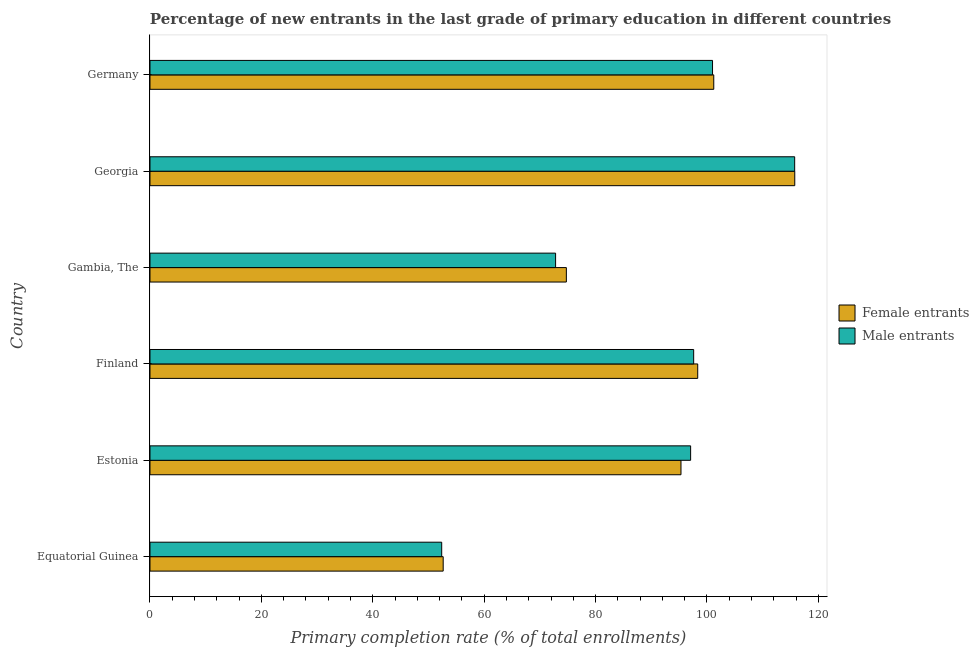How many different coloured bars are there?
Provide a short and direct response. 2. Are the number of bars per tick equal to the number of legend labels?
Keep it short and to the point. Yes. Are the number of bars on each tick of the Y-axis equal?
Offer a very short reply. Yes. How many bars are there on the 5th tick from the bottom?
Give a very brief answer. 2. What is the label of the 2nd group of bars from the top?
Your answer should be very brief. Georgia. What is the primary completion rate of female entrants in Georgia?
Your response must be concise. 115.76. Across all countries, what is the maximum primary completion rate of male entrants?
Your response must be concise. 115.74. Across all countries, what is the minimum primary completion rate of female entrants?
Your response must be concise. 52.64. In which country was the primary completion rate of male entrants maximum?
Provide a short and direct response. Georgia. In which country was the primary completion rate of male entrants minimum?
Make the answer very short. Equatorial Guinea. What is the total primary completion rate of female entrants in the graph?
Give a very brief answer. 538.03. What is the difference between the primary completion rate of female entrants in Estonia and that in Finland?
Offer a very short reply. -3. What is the difference between the primary completion rate of female entrants in Equatorial Guinea and the primary completion rate of male entrants in Gambia, The?
Give a very brief answer. -20.18. What is the average primary completion rate of female entrants per country?
Your answer should be very brief. 89.67. What is the difference between the primary completion rate of female entrants and primary completion rate of male entrants in Germany?
Offer a very short reply. 0.22. In how many countries, is the primary completion rate of female entrants greater than 92 %?
Your answer should be very brief. 4. What is the ratio of the primary completion rate of female entrants in Estonia to that in Georgia?
Provide a short and direct response. 0.82. Is the primary completion rate of male entrants in Georgia less than that in Germany?
Give a very brief answer. No. What is the difference between the highest and the second highest primary completion rate of male entrants?
Ensure brevity in your answer.  14.74. What is the difference between the highest and the lowest primary completion rate of female entrants?
Make the answer very short. 63.12. Is the sum of the primary completion rate of female entrants in Estonia and Gambia, The greater than the maximum primary completion rate of male entrants across all countries?
Provide a short and direct response. Yes. What does the 1st bar from the top in Gambia, The represents?
Your answer should be compact. Male entrants. What does the 1st bar from the bottom in Estonia represents?
Give a very brief answer. Female entrants. Are all the bars in the graph horizontal?
Provide a succinct answer. Yes. How many countries are there in the graph?
Give a very brief answer. 6. Are the values on the major ticks of X-axis written in scientific E-notation?
Your answer should be very brief. No. Does the graph contain any zero values?
Provide a short and direct response. No. Does the graph contain grids?
Offer a terse response. No. Where does the legend appear in the graph?
Provide a succinct answer. Center right. What is the title of the graph?
Offer a very short reply. Percentage of new entrants in the last grade of primary education in different countries. What is the label or title of the X-axis?
Your response must be concise. Primary completion rate (% of total enrollments). What is the Primary completion rate (% of total enrollments) of Female entrants in Equatorial Guinea?
Give a very brief answer. 52.64. What is the Primary completion rate (% of total enrollments) of Male entrants in Equatorial Guinea?
Offer a very short reply. 52.37. What is the Primary completion rate (% of total enrollments) in Female entrants in Estonia?
Give a very brief answer. 95.33. What is the Primary completion rate (% of total enrollments) in Male entrants in Estonia?
Make the answer very short. 97.06. What is the Primary completion rate (% of total enrollments) of Female entrants in Finland?
Provide a succinct answer. 98.33. What is the Primary completion rate (% of total enrollments) in Male entrants in Finland?
Provide a succinct answer. 97.61. What is the Primary completion rate (% of total enrollments) in Female entrants in Gambia, The?
Make the answer very short. 74.75. What is the Primary completion rate (% of total enrollments) in Male entrants in Gambia, The?
Provide a succinct answer. 72.82. What is the Primary completion rate (% of total enrollments) in Female entrants in Georgia?
Make the answer very short. 115.76. What is the Primary completion rate (% of total enrollments) in Male entrants in Georgia?
Provide a succinct answer. 115.74. What is the Primary completion rate (% of total enrollments) of Female entrants in Germany?
Provide a short and direct response. 101.22. What is the Primary completion rate (% of total enrollments) of Male entrants in Germany?
Your answer should be very brief. 101. Across all countries, what is the maximum Primary completion rate (% of total enrollments) in Female entrants?
Give a very brief answer. 115.76. Across all countries, what is the maximum Primary completion rate (% of total enrollments) of Male entrants?
Offer a very short reply. 115.74. Across all countries, what is the minimum Primary completion rate (% of total enrollments) in Female entrants?
Provide a succinct answer. 52.64. Across all countries, what is the minimum Primary completion rate (% of total enrollments) of Male entrants?
Your response must be concise. 52.37. What is the total Primary completion rate (% of total enrollments) in Female entrants in the graph?
Provide a succinct answer. 538.03. What is the total Primary completion rate (% of total enrollments) of Male entrants in the graph?
Give a very brief answer. 536.6. What is the difference between the Primary completion rate (% of total enrollments) in Female entrants in Equatorial Guinea and that in Estonia?
Provide a short and direct response. -42.69. What is the difference between the Primary completion rate (% of total enrollments) of Male entrants in Equatorial Guinea and that in Estonia?
Your response must be concise. -44.69. What is the difference between the Primary completion rate (% of total enrollments) of Female entrants in Equatorial Guinea and that in Finland?
Keep it short and to the point. -45.7. What is the difference between the Primary completion rate (% of total enrollments) of Male entrants in Equatorial Guinea and that in Finland?
Ensure brevity in your answer.  -45.24. What is the difference between the Primary completion rate (% of total enrollments) in Female entrants in Equatorial Guinea and that in Gambia, The?
Your answer should be compact. -22.11. What is the difference between the Primary completion rate (% of total enrollments) in Male entrants in Equatorial Guinea and that in Gambia, The?
Provide a succinct answer. -20.45. What is the difference between the Primary completion rate (% of total enrollments) of Female entrants in Equatorial Guinea and that in Georgia?
Give a very brief answer. -63.12. What is the difference between the Primary completion rate (% of total enrollments) of Male entrants in Equatorial Guinea and that in Georgia?
Provide a short and direct response. -63.37. What is the difference between the Primary completion rate (% of total enrollments) in Female entrants in Equatorial Guinea and that in Germany?
Give a very brief answer. -48.58. What is the difference between the Primary completion rate (% of total enrollments) of Male entrants in Equatorial Guinea and that in Germany?
Make the answer very short. -48.62. What is the difference between the Primary completion rate (% of total enrollments) of Female entrants in Estonia and that in Finland?
Make the answer very short. -3. What is the difference between the Primary completion rate (% of total enrollments) of Male entrants in Estonia and that in Finland?
Your response must be concise. -0.55. What is the difference between the Primary completion rate (% of total enrollments) in Female entrants in Estonia and that in Gambia, The?
Keep it short and to the point. 20.58. What is the difference between the Primary completion rate (% of total enrollments) of Male entrants in Estonia and that in Gambia, The?
Your response must be concise. 24.24. What is the difference between the Primary completion rate (% of total enrollments) in Female entrants in Estonia and that in Georgia?
Offer a very short reply. -20.43. What is the difference between the Primary completion rate (% of total enrollments) in Male entrants in Estonia and that in Georgia?
Provide a short and direct response. -18.68. What is the difference between the Primary completion rate (% of total enrollments) in Female entrants in Estonia and that in Germany?
Offer a terse response. -5.88. What is the difference between the Primary completion rate (% of total enrollments) in Male entrants in Estonia and that in Germany?
Provide a short and direct response. -3.93. What is the difference between the Primary completion rate (% of total enrollments) in Female entrants in Finland and that in Gambia, The?
Provide a succinct answer. 23.58. What is the difference between the Primary completion rate (% of total enrollments) of Male entrants in Finland and that in Gambia, The?
Give a very brief answer. 24.79. What is the difference between the Primary completion rate (% of total enrollments) of Female entrants in Finland and that in Georgia?
Ensure brevity in your answer.  -17.42. What is the difference between the Primary completion rate (% of total enrollments) of Male entrants in Finland and that in Georgia?
Your response must be concise. -18.13. What is the difference between the Primary completion rate (% of total enrollments) of Female entrants in Finland and that in Germany?
Provide a succinct answer. -2.88. What is the difference between the Primary completion rate (% of total enrollments) of Male entrants in Finland and that in Germany?
Give a very brief answer. -3.39. What is the difference between the Primary completion rate (% of total enrollments) of Female entrants in Gambia, The and that in Georgia?
Keep it short and to the point. -41.01. What is the difference between the Primary completion rate (% of total enrollments) in Male entrants in Gambia, The and that in Georgia?
Give a very brief answer. -42.92. What is the difference between the Primary completion rate (% of total enrollments) of Female entrants in Gambia, The and that in Germany?
Offer a very short reply. -26.47. What is the difference between the Primary completion rate (% of total enrollments) in Male entrants in Gambia, The and that in Germany?
Your response must be concise. -28.18. What is the difference between the Primary completion rate (% of total enrollments) of Female entrants in Georgia and that in Germany?
Ensure brevity in your answer.  14.54. What is the difference between the Primary completion rate (% of total enrollments) of Male entrants in Georgia and that in Germany?
Offer a terse response. 14.75. What is the difference between the Primary completion rate (% of total enrollments) of Female entrants in Equatorial Guinea and the Primary completion rate (% of total enrollments) of Male entrants in Estonia?
Keep it short and to the point. -44.43. What is the difference between the Primary completion rate (% of total enrollments) of Female entrants in Equatorial Guinea and the Primary completion rate (% of total enrollments) of Male entrants in Finland?
Provide a short and direct response. -44.97. What is the difference between the Primary completion rate (% of total enrollments) in Female entrants in Equatorial Guinea and the Primary completion rate (% of total enrollments) in Male entrants in Gambia, The?
Ensure brevity in your answer.  -20.18. What is the difference between the Primary completion rate (% of total enrollments) of Female entrants in Equatorial Guinea and the Primary completion rate (% of total enrollments) of Male entrants in Georgia?
Offer a terse response. -63.1. What is the difference between the Primary completion rate (% of total enrollments) in Female entrants in Equatorial Guinea and the Primary completion rate (% of total enrollments) in Male entrants in Germany?
Offer a very short reply. -48.36. What is the difference between the Primary completion rate (% of total enrollments) in Female entrants in Estonia and the Primary completion rate (% of total enrollments) in Male entrants in Finland?
Your response must be concise. -2.28. What is the difference between the Primary completion rate (% of total enrollments) in Female entrants in Estonia and the Primary completion rate (% of total enrollments) in Male entrants in Gambia, The?
Give a very brief answer. 22.51. What is the difference between the Primary completion rate (% of total enrollments) in Female entrants in Estonia and the Primary completion rate (% of total enrollments) in Male entrants in Georgia?
Make the answer very short. -20.41. What is the difference between the Primary completion rate (% of total enrollments) in Female entrants in Estonia and the Primary completion rate (% of total enrollments) in Male entrants in Germany?
Keep it short and to the point. -5.66. What is the difference between the Primary completion rate (% of total enrollments) of Female entrants in Finland and the Primary completion rate (% of total enrollments) of Male entrants in Gambia, The?
Offer a terse response. 25.52. What is the difference between the Primary completion rate (% of total enrollments) of Female entrants in Finland and the Primary completion rate (% of total enrollments) of Male entrants in Georgia?
Give a very brief answer. -17.41. What is the difference between the Primary completion rate (% of total enrollments) in Female entrants in Finland and the Primary completion rate (% of total enrollments) in Male entrants in Germany?
Give a very brief answer. -2.66. What is the difference between the Primary completion rate (% of total enrollments) in Female entrants in Gambia, The and the Primary completion rate (% of total enrollments) in Male entrants in Georgia?
Provide a short and direct response. -40.99. What is the difference between the Primary completion rate (% of total enrollments) of Female entrants in Gambia, The and the Primary completion rate (% of total enrollments) of Male entrants in Germany?
Give a very brief answer. -26.24. What is the difference between the Primary completion rate (% of total enrollments) of Female entrants in Georgia and the Primary completion rate (% of total enrollments) of Male entrants in Germany?
Give a very brief answer. 14.76. What is the average Primary completion rate (% of total enrollments) of Female entrants per country?
Make the answer very short. 89.67. What is the average Primary completion rate (% of total enrollments) of Male entrants per country?
Your answer should be compact. 89.43. What is the difference between the Primary completion rate (% of total enrollments) in Female entrants and Primary completion rate (% of total enrollments) in Male entrants in Equatorial Guinea?
Keep it short and to the point. 0.27. What is the difference between the Primary completion rate (% of total enrollments) in Female entrants and Primary completion rate (% of total enrollments) in Male entrants in Estonia?
Ensure brevity in your answer.  -1.73. What is the difference between the Primary completion rate (% of total enrollments) in Female entrants and Primary completion rate (% of total enrollments) in Male entrants in Finland?
Provide a short and direct response. 0.73. What is the difference between the Primary completion rate (% of total enrollments) in Female entrants and Primary completion rate (% of total enrollments) in Male entrants in Gambia, The?
Your answer should be compact. 1.93. What is the difference between the Primary completion rate (% of total enrollments) of Female entrants and Primary completion rate (% of total enrollments) of Male entrants in Georgia?
Your answer should be very brief. 0.02. What is the difference between the Primary completion rate (% of total enrollments) in Female entrants and Primary completion rate (% of total enrollments) in Male entrants in Germany?
Ensure brevity in your answer.  0.22. What is the ratio of the Primary completion rate (% of total enrollments) of Female entrants in Equatorial Guinea to that in Estonia?
Your response must be concise. 0.55. What is the ratio of the Primary completion rate (% of total enrollments) of Male entrants in Equatorial Guinea to that in Estonia?
Ensure brevity in your answer.  0.54. What is the ratio of the Primary completion rate (% of total enrollments) of Female entrants in Equatorial Guinea to that in Finland?
Your response must be concise. 0.54. What is the ratio of the Primary completion rate (% of total enrollments) in Male entrants in Equatorial Guinea to that in Finland?
Keep it short and to the point. 0.54. What is the ratio of the Primary completion rate (% of total enrollments) in Female entrants in Equatorial Guinea to that in Gambia, The?
Offer a very short reply. 0.7. What is the ratio of the Primary completion rate (% of total enrollments) of Male entrants in Equatorial Guinea to that in Gambia, The?
Offer a terse response. 0.72. What is the ratio of the Primary completion rate (% of total enrollments) in Female entrants in Equatorial Guinea to that in Georgia?
Your response must be concise. 0.45. What is the ratio of the Primary completion rate (% of total enrollments) of Male entrants in Equatorial Guinea to that in Georgia?
Provide a short and direct response. 0.45. What is the ratio of the Primary completion rate (% of total enrollments) of Female entrants in Equatorial Guinea to that in Germany?
Give a very brief answer. 0.52. What is the ratio of the Primary completion rate (% of total enrollments) of Male entrants in Equatorial Guinea to that in Germany?
Your answer should be compact. 0.52. What is the ratio of the Primary completion rate (% of total enrollments) in Female entrants in Estonia to that in Finland?
Make the answer very short. 0.97. What is the ratio of the Primary completion rate (% of total enrollments) of Female entrants in Estonia to that in Gambia, The?
Provide a short and direct response. 1.28. What is the ratio of the Primary completion rate (% of total enrollments) in Male entrants in Estonia to that in Gambia, The?
Offer a very short reply. 1.33. What is the ratio of the Primary completion rate (% of total enrollments) in Female entrants in Estonia to that in Georgia?
Ensure brevity in your answer.  0.82. What is the ratio of the Primary completion rate (% of total enrollments) of Male entrants in Estonia to that in Georgia?
Offer a very short reply. 0.84. What is the ratio of the Primary completion rate (% of total enrollments) in Female entrants in Estonia to that in Germany?
Provide a short and direct response. 0.94. What is the ratio of the Primary completion rate (% of total enrollments) of Male entrants in Estonia to that in Germany?
Keep it short and to the point. 0.96. What is the ratio of the Primary completion rate (% of total enrollments) of Female entrants in Finland to that in Gambia, The?
Make the answer very short. 1.32. What is the ratio of the Primary completion rate (% of total enrollments) in Male entrants in Finland to that in Gambia, The?
Your answer should be very brief. 1.34. What is the ratio of the Primary completion rate (% of total enrollments) of Female entrants in Finland to that in Georgia?
Make the answer very short. 0.85. What is the ratio of the Primary completion rate (% of total enrollments) of Male entrants in Finland to that in Georgia?
Offer a terse response. 0.84. What is the ratio of the Primary completion rate (% of total enrollments) in Female entrants in Finland to that in Germany?
Provide a short and direct response. 0.97. What is the ratio of the Primary completion rate (% of total enrollments) of Male entrants in Finland to that in Germany?
Provide a succinct answer. 0.97. What is the ratio of the Primary completion rate (% of total enrollments) in Female entrants in Gambia, The to that in Georgia?
Offer a very short reply. 0.65. What is the ratio of the Primary completion rate (% of total enrollments) in Male entrants in Gambia, The to that in Georgia?
Your response must be concise. 0.63. What is the ratio of the Primary completion rate (% of total enrollments) of Female entrants in Gambia, The to that in Germany?
Make the answer very short. 0.74. What is the ratio of the Primary completion rate (% of total enrollments) in Male entrants in Gambia, The to that in Germany?
Ensure brevity in your answer.  0.72. What is the ratio of the Primary completion rate (% of total enrollments) of Female entrants in Georgia to that in Germany?
Your answer should be compact. 1.14. What is the ratio of the Primary completion rate (% of total enrollments) of Male entrants in Georgia to that in Germany?
Make the answer very short. 1.15. What is the difference between the highest and the second highest Primary completion rate (% of total enrollments) of Female entrants?
Your answer should be very brief. 14.54. What is the difference between the highest and the second highest Primary completion rate (% of total enrollments) in Male entrants?
Offer a very short reply. 14.75. What is the difference between the highest and the lowest Primary completion rate (% of total enrollments) of Female entrants?
Ensure brevity in your answer.  63.12. What is the difference between the highest and the lowest Primary completion rate (% of total enrollments) of Male entrants?
Provide a succinct answer. 63.37. 